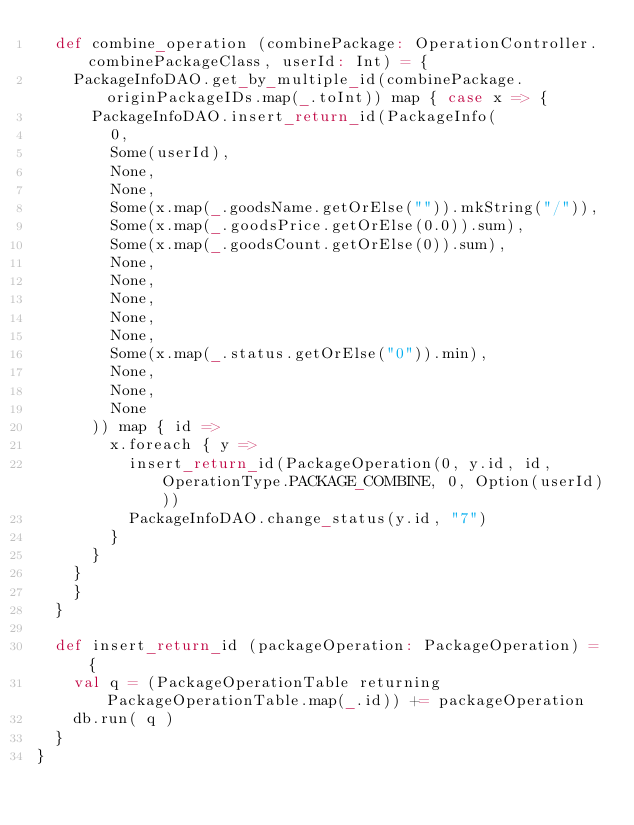Convert code to text. <code><loc_0><loc_0><loc_500><loc_500><_Scala_>  def combine_operation (combinePackage: OperationController.combinePackageClass, userId: Int) = {
    PackageInfoDAO.get_by_multiple_id(combinePackage.originPackageIDs.map(_.toInt)) map { case x => {
      PackageInfoDAO.insert_return_id(PackageInfo(
        0,
        Some(userId),
        None,
        None,
        Some(x.map(_.goodsName.getOrElse("")).mkString("/")),
        Some(x.map(_.goodsPrice.getOrElse(0.0)).sum),
        Some(x.map(_.goodsCount.getOrElse(0)).sum),
        None,
        None,
        None,
        None,
        None,
        Some(x.map(_.status.getOrElse("0")).min),
        None,
        None,
        None
      )) map { id =>
        x.foreach { y =>
          insert_return_id(PackageOperation(0, y.id, id, OperationType.PACKAGE_COMBINE, 0, Option(userId)))
          PackageInfoDAO.change_status(y.id, "7")
        }
      }
    }
    }
  }

  def insert_return_id (packageOperation: PackageOperation) = {
    val q = (PackageOperationTable returning PackageOperationTable.map(_.id)) += packageOperation
    db.run( q )
  }
}
</code> 